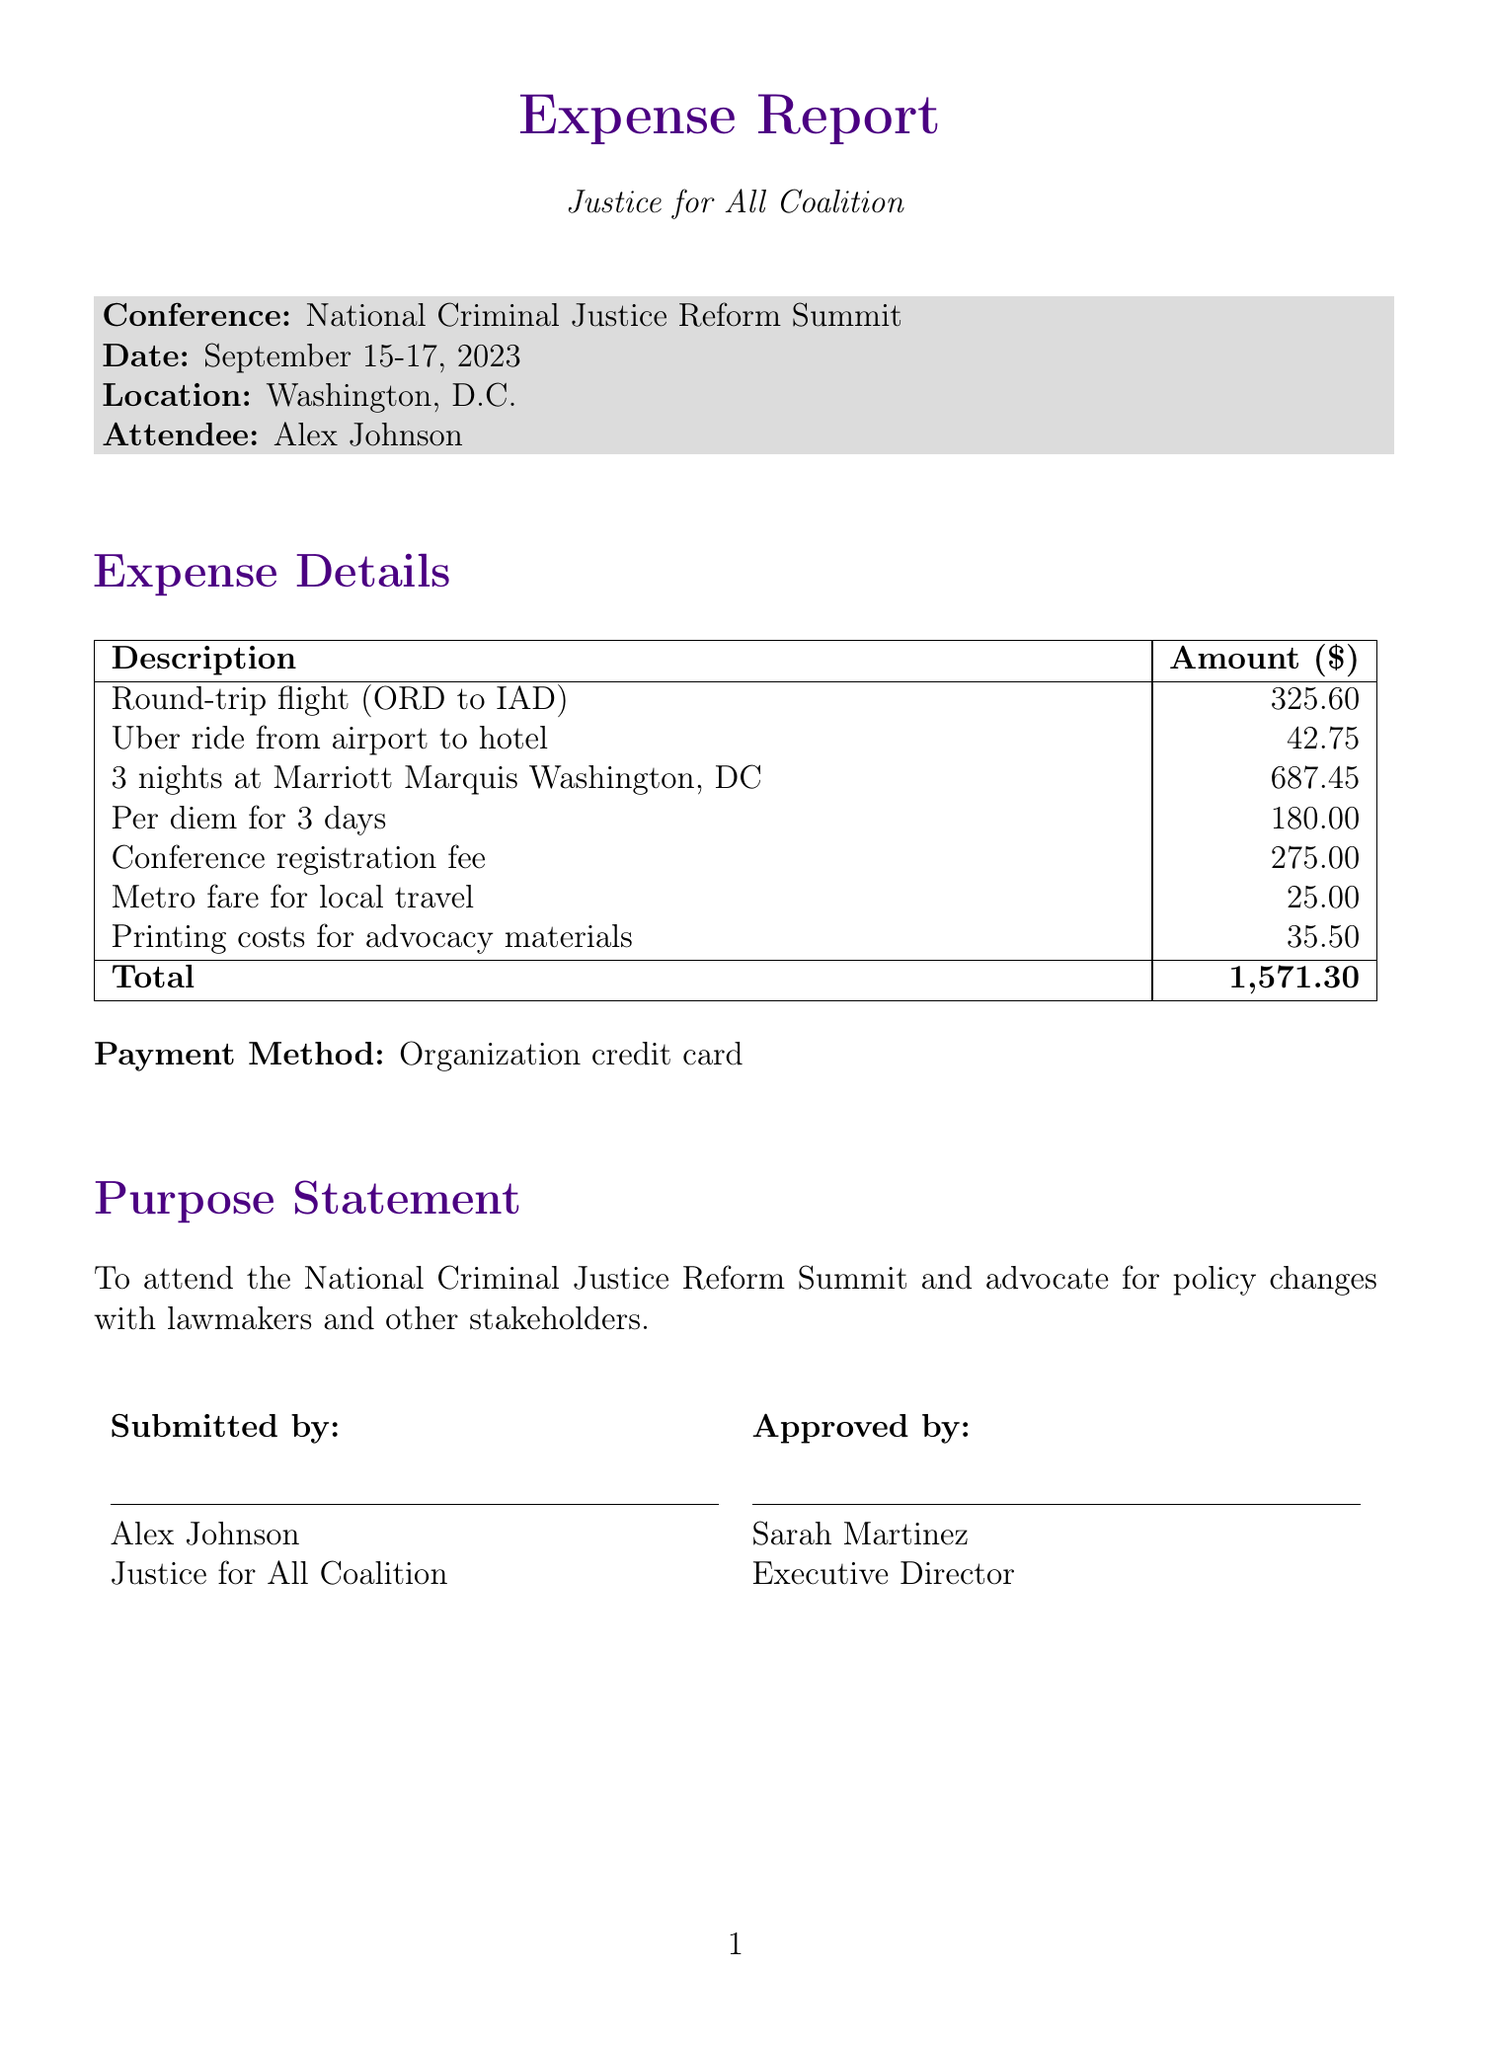what is the conference name? The conference name is mentioned in the document as "National Criminal Justice Reform Summit."
Answer: National Criminal Justice Reform Summit who is the attendee? The attendee's name is listed in the document as "Alex Johnson."
Answer: Alex Johnson what is the total amount of expenses? The total expenses sum is provided in the document as $1,571.30.
Answer: 1,571.30 how many nights was lodging booked for? The lodging details specify that the stay was for 3 nights at the Marriott Marquis.
Answer: 3 nights what was the purpose of the trip? The purpose statement in the document explains the trip was to advocate for policy changes at the summit.
Answer: To attend the National Criminal Justice Reform Summit and advocate for policy changes with lawmakers and other stakeholders who approved the expense report? The approver's name and title are provided in the document, indicating "Sarah Martinez, Executive Director."
Answer: Sarah Martinez what was the payment method used for expenses? The document specifies that the payment was made using the organization credit card.
Answer: Organization credit card what is the registration fee for the conference? The document lists the registration fee as a separate expense item.
Answer: 275.00 which airline was used for the flight? The document mentions "United Airlines" as the airline for the round-trip flight.
Answer: United Airlines 